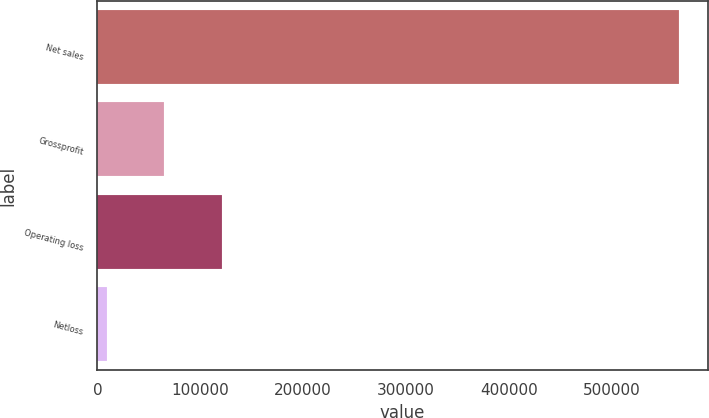<chart> <loc_0><loc_0><loc_500><loc_500><bar_chart><fcel>Net sales<fcel>Grossprofit<fcel>Operating loss<fcel>Netloss<nl><fcel>565037<fcel>65159.9<fcel>120702<fcel>9618<nl></chart> 